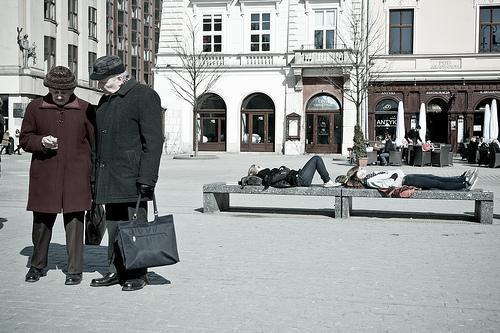How many people are holding a bag?
Give a very brief answer. 2. How many people are laying down?
Give a very brief answer. 2. 